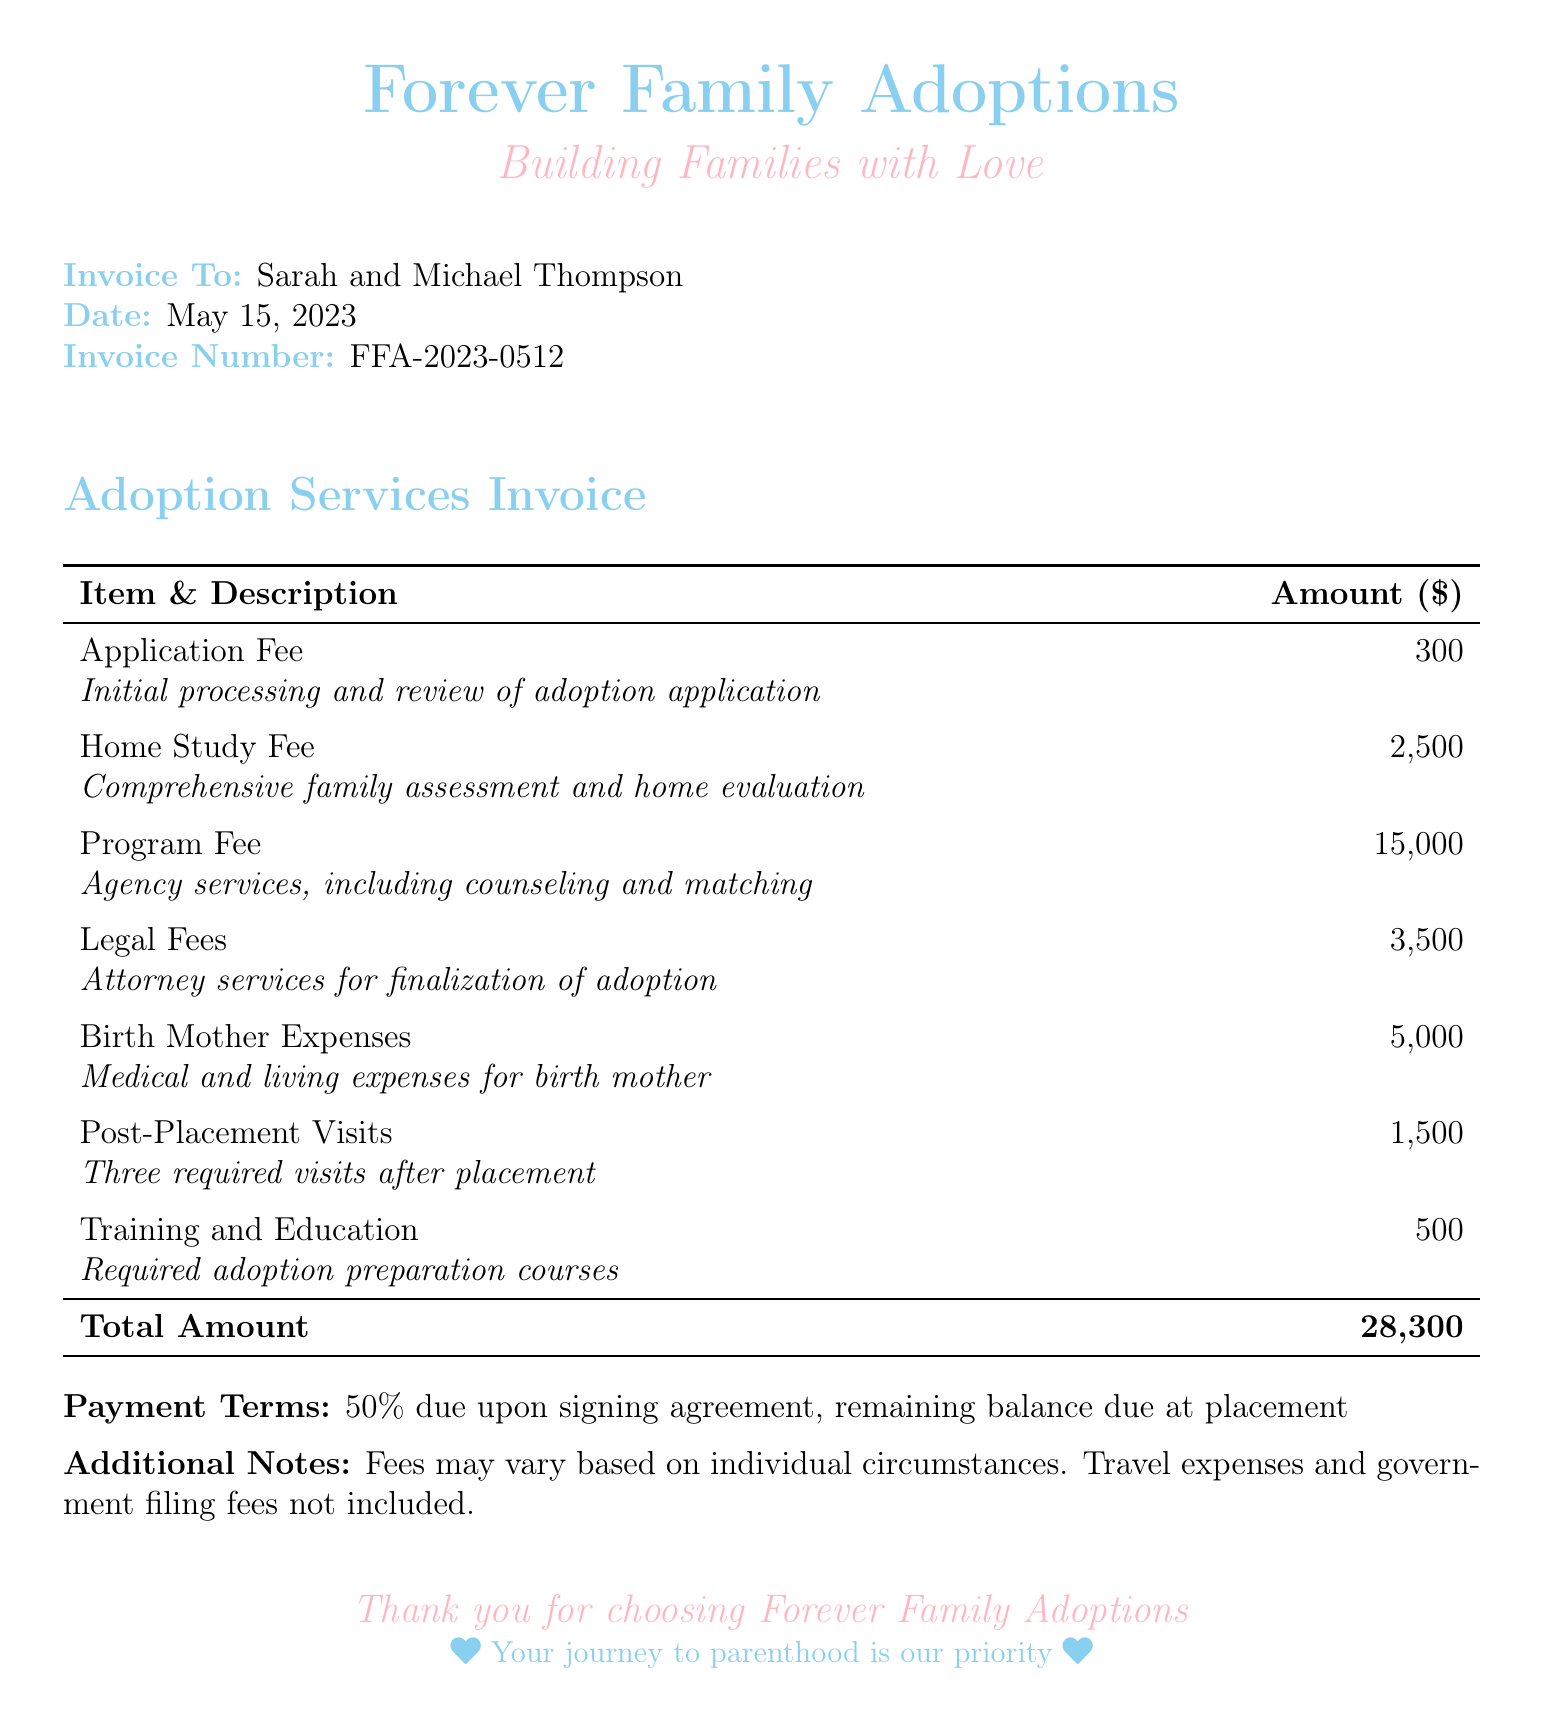what is the application fee? The document lists the application fee as one of the costs for adoption services, specifically stating it is $300.
Answer: $300 what is the total amount due? The total amount is provided at the end of the invoice, summing all the fees listed, which equals $28,300.
Answer: $28,300 how many post-placement visits are included? The document specifies that there are three required post-placement visits as part of the services.
Answer: three what date is the invoice dated? The date of the invoice is important for tracking and reference, which is listed as May 15, 2023.
Answer: May 15, 2023 what is included in the program fee? The program fee description mentions it covers agency services, counseling, and matching, which are crucial parts of the adoption process.
Answer: agency services, counseling, and matching what percentage is due upon signing the agreement? The payment terms state that 50% of the total amount is due upon signing the agreement.
Answer: 50% who is the invoice addressed to? The invoice clearly lists the names of the individuals the invoice is addressed to, identifying them as Sarah and Michael Thompson.
Answer: Sarah and Michael Thompson what type of document is this? This document is categorized as an invoice, which details the costs associated with adoption services.
Answer: invoice 